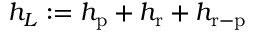<formula> <loc_0><loc_0><loc_500><loc_500>h _ { L } \colon = h _ { p } + h _ { r } + h _ { r - p }</formula> 